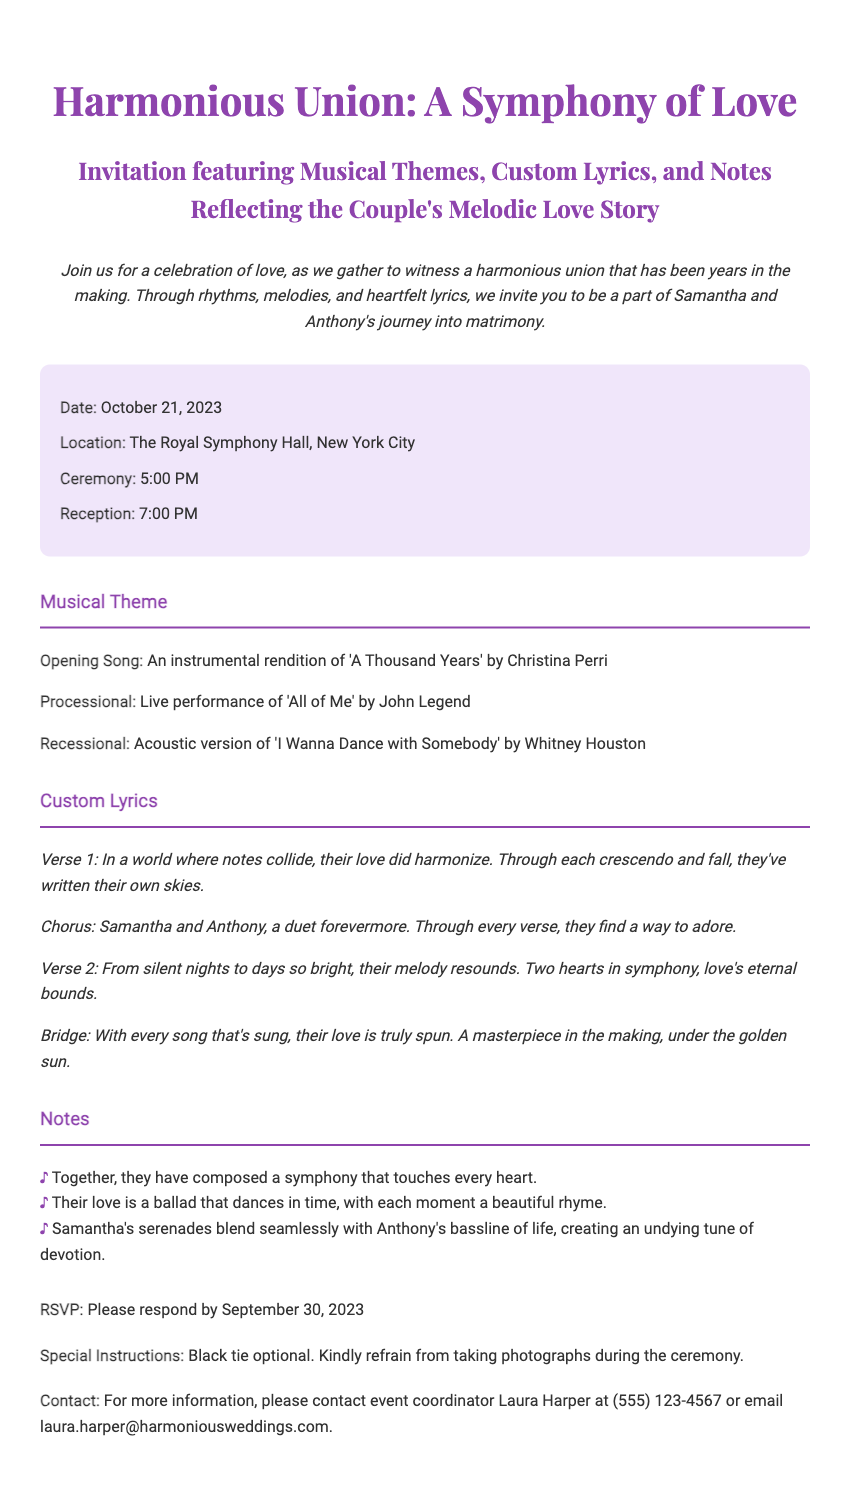What is the date of the wedding? The date of the wedding is clearly stated in the document, which is October 21, 2023.
Answer: October 21, 2023 What is the location of the ceremony? The document specifies that the ceremony will take place at The Royal Symphony Hall in New York City.
Answer: The Royal Symphony Hall, New York City What time does the reception start? The reception time is mentioned in the details section of the document as 7:00 PM.
Answer: 7:00 PM Who is the opening song by? The opening song is identified in the musical theme section of the document as being an instrumental rendition of 'A Thousand Years' by Christina Perri.
Answer: Christina Perri What is the theme of the wedding invitation? The title of the invitation indicates that the theme revolves around a "Symphony of Love" highlighting musical elements.
Answer: Symphony of Love What is the name of the event coordinator? The document provides the name of the event coordinator as Laura Harper.
Answer: Laura Harper What is the RSVP deadline? The RSVP deadline is stated explicitly in the document as September 30, 2023.
Answer: September 30, 2023 What type of dress code is indicated? The document mentions that the dress code is black tie optional.
Answer: Black tie optional What unique feature is included in the wedding invitation? The invitation uniquely features custom lyrics that reflect the couple's love story, as stated in the document.
Answer: Custom lyrics 